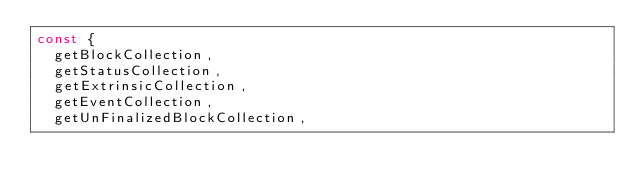<code> <loc_0><loc_0><loc_500><loc_500><_JavaScript_>const {
  getBlockCollection,
  getStatusCollection,
  getExtrinsicCollection,
  getEventCollection,
  getUnFinalizedBlockCollection,</code> 